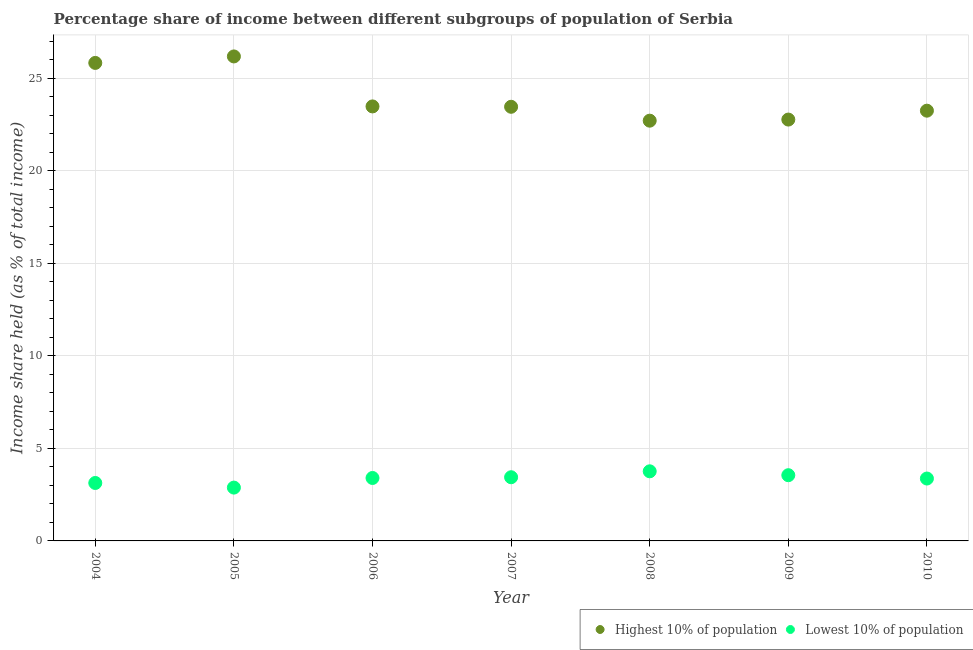What is the income share held by lowest 10% of the population in 2009?
Provide a short and direct response. 3.55. Across all years, what is the maximum income share held by highest 10% of the population?
Offer a very short reply. 26.17. Across all years, what is the minimum income share held by lowest 10% of the population?
Ensure brevity in your answer.  2.88. In which year was the income share held by lowest 10% of the population minimum?
Ensure brevity in your answer.  2005. What is the total income share held by lowest 10% of the population in the graph?
Provide a succinct answer. 23.53. What is the difference between the income share held by highest 10% of the population in 2006 and that in 2007?
Offer a terse response. 0.02. What is the difference between the income share held by lowest 10% of the population in 2007 and the income share held by highest 10% of the population in 2004?
Provide a short and direct response. -22.38. What is the average income share held by highest 10% of the population per year?
Give a very brief answer. 23.94. In the year 2004, what is the difference between the income share held by highest 10% of the population and income share held by lowest 10% of the population?
Your answer should be compact. 22.69. In how many years, is the income share held by highest 10% of the population greater than 1 %?
Ensure brevity in your answer.  7. What is the ratio of the income share held by lowest 10% of the population in 2008 to that in 2009?
Keep it short and to the point. 1.06. Is the income share held by lowest 10% of the population in 2004 less than that in 2007?
Your answer should be compact. Yes. Is the difference between the income share held by highest 10% of the population in 2006 and 2008 greater than the difference between the income share held by lowest 10% of the population in 2006 and 2008?
Offer a very short reply. Yes. What is the difference between the highest and the second highest income share held by highest 10% of the population?
Offer a terse response. 0.35. What is the difference between the highest and the lowest income share held by lowest 10% of the population?
Provide a succinct answer. 0.88. Is the sum of the income share held by highest 10% of the population in 2004 and 2009 greater than the maximum income share held by lowest 10% of the population across all years?
Your answer should be compact. Yes. Is the income share held by lowest 10% of the population strictly greater than the income share held by highest 10% of the population over the years?
Your answer should be compact. No. Is the income share held by highest 10% of the population strictly less than the income share held by lowest 10% of the population over the years?
Provide a succinct answer. No. How many dotlines are there?
Offer a terse response. 2. How many years are there in the graph?
Make the answer very short. 7. What is the difference between two consecutive major ticks on the Y-axis?
Your answer should be compact. 5. Does the graph contain any zero values?
Provide a succinct answer. No. Does the graph contain grids?
Your response must be concise. Yes. Where does the legend appear in the graph?
Offer a very short reply. Bottom right. How are the legend labels stacked?
Keep it short and to the point. Horizontal. What is the title of the graph?
Your answer should be very brief. Percentage share of income between different subgroups of population of Serbia. Does "All education staff compensation" appear as one of the legend labels in the graph?
Ensure brevity in your answer.  No. What is the label or title of the X-axis?
Provide a succinct answer. Year. What is the label or title of the Y-axis?
Your response must be concise. Income share held (as % of total income). What is the Income share held (as % of total income) of Highest 10% of population in 2004?
Provide a succinct answer. 25.82. What is the Income share held (as % of total income) in Lowest 10% of population in 2004?
Keep it short and to the point. 3.13. What is the Income share held (as % of total income) in Highest 10% of population in 2005?
Give a very brief answer. 26.17. What is the Income share held (as % of total income) of Lowest 10% of population in 2005?
Give a very brief answer. 2.88. What is the Income share held (as % of total income) in Highest 10% of population in 2006?
Give a very brief answer. 23.47. What is the Income share held (as % of total income) of Lowest 10% of population in 2006?
Give a very brief answer. 3.4. What is the Income share held (as % of total income) of Highest 10% of population in 2007?
Offer a very short reply. 23.45. What is the Income share held (as % of total income) in Lowest 10% of population in 2007?
Your answer should be very brief. 3.44. What is the Income share held (as % of total income) of Highest 10% of population in 2008?
Your response must be concise. 22.7. What is the Income share held (as % of total income) of Lowest 10% of population in 2008?
Ensure brevity in your answer.  3.76. What is the Income share held (as % of total income) in Highest 10% of population in 2009?
Offer a very short reply. 22.76. What is the Income share held (as % of total income) in Lowest 10% of population in 2009?
Ensure brevity in your answer.  3.55. What is the Income share held (as % of total income) of Highest 10% of population in 2010?
Provide a short and direct response. 23.24. What is the Income share held (as % of total income) of Lowest 10% of population in 2010?
Make the answer very short. 3.37. Across all years, what is the maximum Income share held (as % of total income) in Highest 10% of population?
Make the answer very short. 26.17. Across all years, what is the maximum Income share held (as % of total income) in Lowest 10% of population?
Offer a terse response. 3.76. Across all years, what is the minimum Income share held (as % of total income) of Highest 10% of population?
Make the answer very short. 22.7. Across all years, what is the minimum Income share held (as % of total income) of Lowest 10% of population?
Give a very brief answer. 2.88. What is the total Income share held (as % of total income) of Highest 10% of population in the graph?
Give a very brief answer. 167.61. What is the total Income share held (as % of total income) of Lowest 10% of population in the graph?
Give a very brief answer. 23.53. What is the difference between the Income share held (as % of total income) of Highest 10% of population in 2004 and that in 2005?
Keep it short and to the point. -0.35. What is the difference between the Income share held (as % of total income) in Highest 10% of population in 2004 and that in 2006?
Offer a terse response. 2.35. What is the difference between the Income share held (as % of total income) of Lowest 10% of population in 2004 and that in 2006?
Provide a short and direct response. -0.27. What is the difference between the Income share held (as % of total income) of Highest 10% of population in 2004 and that in 2007?
Give a very brief answer. 2.37. What is the difference between the Income share held (as % of total income) of Lowest 10% of population in 2004 and that in 2007?
Keep it short and to the point. -0.31. What is the difference between the Income share held (as % of total income) in Highest 10% of population in 2004 and that in 2008?
Provide a short and direct response. 3.12. What is the difference between the Income share held (as % of total income) of Lowest 10% of population in 2004 and that in 2008?
Ensure brevity in your answer.  -0.63. What is the difference between the Income share held (as % of total income) of Highest 10% of population in 2004 and that in 2009?
Your response must be concise. 3.06. What is the difference between the Income share held (as % of total income) of Lowest 10% of population in 2004 and that in 2009?
Offer a terse response. -0.42. What is the difference between the Income share held (as % of total income) of Highest 10% of population in 2004 and that in 2010?
Provide a succinct answer. 2.58. What is the difference between the Income share held (as % of total income) in Lowest 10% of population in 2004 and that in 2010?
Provide a succinct answer. -0.24. What is the difference between the Income share held (as % of total income) of Lowest 10% of population in 2005 and that in 2006?
Ensure brevity in your answer.  -0.52. What is the difference between the Income share held (as % of total income) of Highest 10% of population in 2005 and that in 2007?
Your answer should be very brief. 2.72. What is the difference between the Income share held (as % of total income) in Lowest 10% of population in 2005 and that in 2007?
Give a very brief answer. -0.56. What is the difference between the Income share held (as % of total income) in Highest 10% of population in 2005 and that in 2008?
Make the answer very short. 3.47. What is the difference between the Income share held (as % of total income) of Lowest 10% of population in 2005 and that in 2008?
Offer a terse response. -0.88. What is the difference between the Income share held (as % of total income) of Highest 10% of population in 2005 and that in 2009?
Provide a short and direct response. 3.41. What is the difference between the Income share held (as % of total income) in Lowest 10% of population in 2005 and that in 2009?
Your answer should be very brief. -0.67. What is the difference between the Income share held (as % of total income) in Highest 10% of population in 2005 and that in 2010?
Give a very brief answer. 2.93. What is the difference between the Income share held (as % of total income) in Lowest 10% of population in 2005 and that in 2010?
Ensure brevity in your answer.  -0.49. What is the difference between the Income share held (as % of total income) of Lowest 10% of population in 2006 and that in 2007?
Your answer should be very brief. -0.04. What is the difference between the Income share held (as % of total income) of Highest 10% of population in 2006 and that in 2008?
Give a very brief answer. 0.77. What is the difference between the Income share held (as % of total income) of Lowest 10% of population in 2006 and that in 2008?
Give a very brief answer. -0.36. What is the difference between the Income share held (as % of total income) in Highest 10% of population in 2006 and that in 2009?
Your answer should be very brief. 0.71. What is the difference between the Income share held (as % of total income) in Lowest 10% of population in 2006 and that in 2009?
Offer a terse response. -0.15. What is the difference between the Income share held (as % of total income) of Highest 10% of population in 2006 and that in 2010?
Your response must be concise. 0.23. What is the difference between the Income share held (as % of total income) of Highest 10% of population in 2007 and that in 2008?
Your response must be concise. 0.75. What is the difference between the Income share held (as % of total income) in Lowest 10% of population in 2007 and that in 2008?
Your answer should be compact. -0.32. What is the difference between the Income share held (as % of total income) in Highest 10% of population in 2007 and that in 2009?
Make the answer very short. 0.69. What is the difference between the Income share held (as % of total income) in Lowest 10% of population in 2007 and that in 2009?
Give a very brief answer. -0.11. What is the difference between the Income share held (as % of total income) in Highest 10% of population in 2007 and that in 2010?
Give a very brief answer. 0.21. What is the difference between the Income share held (as % of total income) in Lowest 10% of population in 2007 and that in 2010?
Provide a short and direct response. 0.07. What is the difference between the Income share held (as % of total income) in Highest 10% of population in 2008 and that in 2009?
Provide a short and direct response. -0.06. What is the difference between the Income share held (as % of total income) in Lowest 10% of population in 2008 and that in 2009?
Your response must be concise. 0.21. What is the difference between the Income share held (as % of total income) in Highest 10% of population in 2008 and that in 2010?
Your answer should be very brief. -0.54. What is the difference between the Income share held (as % of total income) of Lowest 10% of population in 2008 and that in 2010?
Provide a short and direct response. 0.39. What is the difference between the Income share held (as % of total income) in Highest 10% of population in 2009 and that in 2010?
Make the answer very short. -0.48. What is the difference between the Income share held (as % of total income) of Lowest 10% of population in 2009 and that in 2010?
Provide a succinct answer. 0.18. What is the difference between the Income share held (as % of total income) of Highest 10% of population in 2004 and the Income share held (as % of total income) of Lowest 10% of population in 2005?
Your answer should be compact. 22.94. What is the difference between the Income share held (as % of total income) of Highest 10% of population in 2004 and the Income share held (as % of total income) of Lowest 10% of population in 2006?
Keep it short and to the point. 22.42. What is the difference between the Income share held (as % of total income) in Highest 10% of population in 2004 and the Income share held (as % of total income) in Lowest 10% of population in 2007?
Keep it short and to the point. 22.38. What is the difference between the Income share held (as % of total income) in Highest 10% of population in 2004 and the Income share held (as % of total income) in Lowest 10% of population in 2008?
Provide a succinct answer. 22.06. What is the difference between the Income share held (as % of total income) of Highest 10% of population in 2004 and the Income share held (as % of total income) of Lowest 10% of population in 2009?
Give a very brief answer. 22.27. What is the difference between the Income share held (as % of total income) in Highest 10% of population in 2004 and the Income share held (as % of total income) in Lowest 10% of population in 2010?
Ensure brevity in your answer.  22.45. What is the difference between the Income share held (as % of total income) of Highest 10% of population in 2005 and the Income share held (as % of total income) of Lowest 10% of population in 2006?
Ensure brevity in your answer.  22.77. What is the difference between the Income share held (as % of total income) in Highest 10% of population in 2005 and the Income share held (as % of total income) in Lowest 10% of population in 2007?
Offer a very short reply. 22.73. What is the difference between the Income share held (as % of total income) of Highest 10% of population in 2005 and the Income share held (as % of total income) of Lowest 10% of population in 2008?
Ensure brevity in your answer.  22.41. What is the difference between the Income share held (as % of total income) in Highest 10% of population in 2005 and the Income share held (as % of total income) in Lowest 10% of population in 2009?
Provide a succinct answer. 22.62. What is the difference between the Income share held (as % of total income) of Highest 10% of population in 2005 and the Income share held (as % of total income) of Lowest 10% of population in 2010?
Offer a very short reply. 22.8. What is the difference between the Income share held (as % of total income) of Highest 10% of population in 2006 and the Income share held (as % of total income) of Lowest 10% of population in 2007?
Your response must be concise. 20.03. What is the difference between the Income share held (as % of total income) in Highest 10% of population in 2006 and the Income share held (as % of total income) in Lowest 10% of population in 2008?
Give a very brief answer. 19.71. What is the difference between the Income share held (as % of total income) of Highest 10% of population in 2006 and the Income share held (as % of total income) of Lowest 10% of population in 2009?
Provide a short and direct response. 19.92. What is the difference between the Income share held (as % of total income) in Highest 10% of population in 2006 and the Income share held (as % of total income) in Lowest 10% of population in 2010?
Your response must be concise. 20.1. What is the difference between the Income share held (as % of total income) in Highest 10% of population in 2007 and the Income share held (as % of total income) in Lowest 10% of population in 2008?
Provide a succinct answer. 19.69. What is the difference between the Income share held (as % of total income) of Highest 10% of population in 2007 and the Income share held (as % of total income) of Lowest 10% of population in 2009?
Your answer should be very brief. 19.9. What is the difference between the Income share held (as % of total income) of Highest 10% of population in 2007 and the Income share held (as % of total income) of Lowest 10% of population in 2010?
Your answer should be very brief. 20.08. What is the difference between the Income share held (as % of total income) of Highest 10% of population in 2008 and the Income share held (as % of total income) of Lowest 10% of population in 2009?
Give a very brief answer. 19.15. What is the difference between the Income share held (as % of total income) in Highest 10% of population in 2008 and the Income share held (as % of total income) in Lowest 10% of population in 2010?
Give a very brief answer. 19.33. What is the difference between the Income share held (as % of total income) of Highest 10% of population in 2009 and the Income share held (as % of total income) of Lowest 10% of population in 2010?
Keep it short and to the point. 19.39. What is the average Income share held (as % of total income) of Highest 10% of population per year?
Ensure brevity in your answer.  23.94. What is the average Income share held (as % of total income) of Lowest 10% of population per year?
Your answer should be compact. 3.36. In the year 2004, what is the difference between the Income share held (as % of total income) of Highest 10% of population and Income share held (as % of total income) of Lowest 10% of population?
Provide a succinct answer. 22.69. In the year 2005, what is the difference between the Income share held (as % of total income) of Highest 10% of population and Income share held (as % of total income) of Lowest 10% of population?
Make the answer very short. 23.29. In the year 2006, what is the difference between the Income share held (as % of total income) in Highest 10% of population and Income share held (as % of total income) in Lowest 10% of population?
Provide a short and direct response. 20.07. In the year 2007, what is the difference between the Income share held (as % of total income) in Highest 10% of population and Income share held (as % of total income) in Lowest 10% of population?
Offer a terse response. 20.01. In the year 2008, what is the difference between the Income share held (as % of total income) of Highest 10% of population and Income share held (as % of total income) of Lowest 10% of population?
Give a very brief answer. 18.94. In the year 2009, what is the difference between the Income share held (as % of total income) in Highest 10% of population and Income share held (as % of total income) in Lowest 10% of population?
Provide a short and direct response. 19.21. In the year 2010, what is the difference between the Income share held (as % of total income) in Highest 10% of population and Income share held (as % of total income) in Lowest 10% of population?
Give a very brief answer. 19.87. What is the ratio of the Income share held (as % of total income) in Highest 10% of population in 2004 to that in 2005?
Ensure brevity in your answer.  0.99. What is the ratio of the Income share held (as % of total income) in Lowest 10% of population in 2004 to that in 2005?
Your response must be concise. 1.09. What is the ratio of the Income share held (as % of total income) in Highest 10% of population in 2004 to that in 2006?
Provide a succinct answer. 1.1. What is the ratio of the Income share held (as % of total income) of Lowest 10% of population in 2004 to that in 2006?
Offer a very short reply. 0.92. What is the ratio of the Income share held (as % of total income) in Highest 10% of population in 2004 to that in 2007?
Provide a succinct answer. 1.1. What is the ratio of the Income share held (as % of total income) of Lowest 10% of population in 2004 to that in 2007?
Give a very brief answer. 0.91. What is the ratio of the Income share held (as % of total income) in Highest 10% of population in 2004 to that in 2008?
Provide a short and direct response. 1.14. What is the ratio of the Income share held (as % of total income) in Lowest 10% of population in 2004 to that in 2008?
Your response must be concise. 0.83. What is the ratio of the Income share held (as % of total income) of Highest 10% of population in 2004 to that in 2009?
Your answer should be very brief. 1.13. What is the ratio of the Income share held (as % of total income) in Lowest 10% of population in 2004 to that in 2009?
Provide a succinct answer. 0.88. What is the ratio of the Income share held (as % of total income) of Highest 10% of population in 2004 to that in 2010?
Provide a short and direct response. 1.11. What is the ratio of the Income share held (as % of total income) in Lowest 10% of population in 2004 to that in 2010?
Provide a short and direct response. 0.93. What is the ratio of the Income share held (as % of total income) in Highest 10% of population in 2005 to that in 2006?
Make the answer very short. 1.11. What is the ratio of the Income share held (as % of total income) of Lowest 10% of population in 2005 to that in 2006?
Provide a short and direct response. 0.85. What is the ratio of the Income share held (as % of total income) in Highest 10% of population in 2005 to that in 2007?
Provide a short and direct response. 1.12. What is the ratio of the Income share held (as % of total income) in Lowest 10% of population in 2005 to that in 2007?
Provide a succinct answer. 0.84. What is the ratio of the Income share held (as % of total income) of Highest 10% of population in 2005 to that in 2008?
Your answer should be very brief. 1.15. What is the ratio of the Income share held (as % of total income) of Lowest 10% of population in 2005 to that in 2008?
Provide a short and direct response. 0.77. What is the ratio of the Income share held (as % of total income) in Highest 10% of population in 2005 to that in 2009?
Give a very brief answer. 1.15. What is the ratio of the Income share held (as % of total income) in Lowest 10% of population in 2005 to that in 2009?
Provide a succinct answer. 0.81. What is the ratio of the Income share held (as % of total income) of Highest 10% of population in 2005 to that in 2010?
Your response must be concise. 1.13. What is the ratio of the Income share held (as % of total income) of Lowest 10% of population in 2005 to that in 2010?
Your answer should be very brief. 0.85. What is the ratio of the Income share held (as % of total income) of Highest 10% of population in 2006 to that in 2007?
Ensure brevity in your answer.  1. What is the ratio of the Income share held (as % of total income) in Lowest 10% of population in 2006 to that in 2007?
Offer a very short reply. 0.99. What is the ratio of the Income share held (as % of total income) in Highest 10% of population in 2006 to that in 2008?
Your answer should be very brief. 1.03. What is the ratio of the Income share held (as % of total income) in Lowest 10% of population in 2006 to that in 2008?
Keep it short and to the point. 0.9. What is the ratio of the Income share held (as % of total income) of Highest 10% of population in 2006 to that in 2009?
Keep it short and to the point. 1.03. What is the ratio of the Income share held (as % of total income) in Lowest 10% of population in 2006 to that in 2009?
Provide a succinct answer. 0.96. What is the ratio of the Income share held (as % of total income) in Highest 10% of population in 2006 to that in 2010?
Give a very brief answer. 1.01. What is the ratio of the Income share held (as % of total income) in Lowest 10% of population in 2006 to that in 2010?
Offer a very short reply. 1.01. What is the ratio of the Income share held (as % of total income) in Highest 10% of population in 2007 to that in 2008?
Your answer should be very brief. 1.03. What is the ratio of the Income share held (as % of total income) of Lowest 10% of population in 2007 to that in 2008?
Keep it short and to the point. 0.91. What is the ratio of the Income share held (as % of total income) of Highest 10% of population in 2007 to that in 2009?
Your response must be concise. 1.03. What is the ratio of the Income share held (as % of total income) of Lowest 10% of population in 2007 to that in 2010?
Ensure brevity in your answer.  1.02. What is the ratio of the Income share held (as % of total income) of Highest 10% of population in 2008 to that in 2009?
Provide a succinct answer. 1. What is the ratio of the Income share held (as % of total income) in Lowest 10% of population in 2008 to that in 2009?
Keep it short and to the point. 1.06. What is the ratio of the Income share held (as % of total income) of Highest 10% of population in 2008 to that in 2010?
Ensure brevity in your answer.  0.98. What is the ratio of the Income share held (as % of total income) in Lowest 10% of population in 2008 to that in 2010?
Offer a very short reply. 1.12. What is the ratio of the Income share held (as % of total income) in Highest 10% of population in 2009 to that in 2010?
Your answer should be very brief. 0.98. What is the ratio of the Income share held (as % of total income) of Lowest 10% of population in 2009 to that in 2010?
Ensure brevity in your answer.  1.05. What is the difference between the highest and the second highest Income share held (as % of total income) in Highest 10% of population?
Make the answer very short. 0.35. What is the difference between the highest and the second highest Income share held (as % of total income) of Lowest 10% of population?
Make the answer very short. 0.21. What is the difference between the highest and the lowest Income share held (as % of total income) in Highest 10% of population?
Offer a terse response. 3.47. 